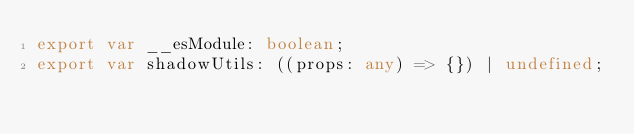<code> <loc_0><loc_0><loc_500><loc_500><_TypeScript_>export var __esModule: boolean;
export var shadowUtils: ((props: any) => {}) | undefined;
</code> 